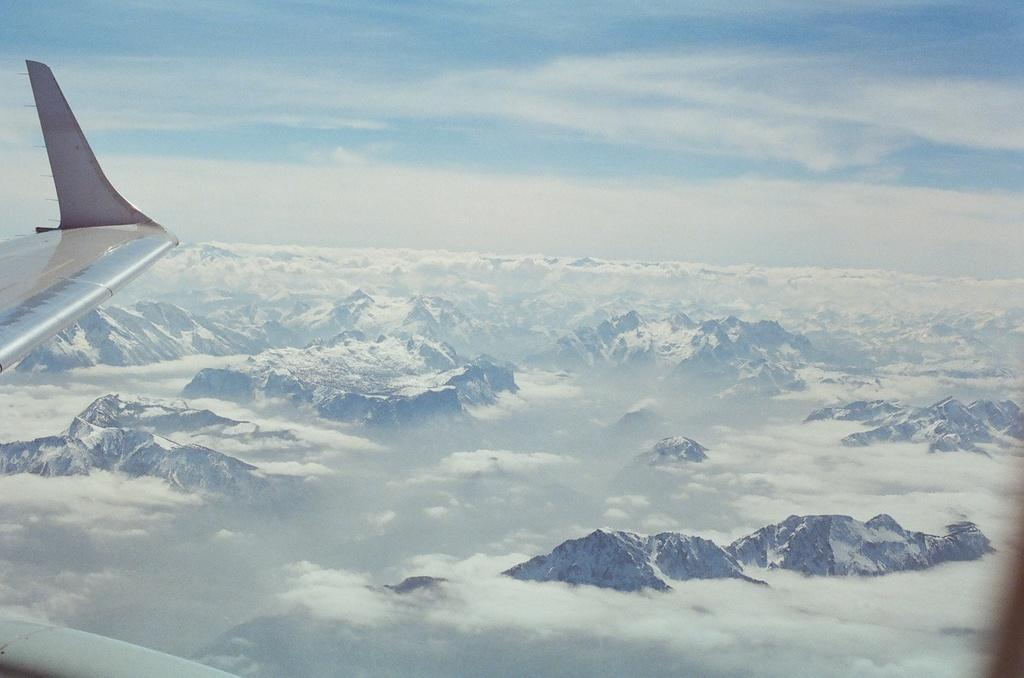What can be seen on the left side of the image? There is a wing of a plane on the left side of the image. What type of landscape is visible in the image? There are mountains covered with snow in the image. What else is present in the sky besides the mountains? There are clouds in the image. What is visible at the top of the image? The sky is visible at the top of the image. What type of grass is growing on the wing of the plane in the image? There is no grass growing on the wing of the plane in the image. What thrill can be experienced while flying through the mountains in the image? The image does not depict a flying experience, so it is not possible to determine the thrill that might be experienced. 